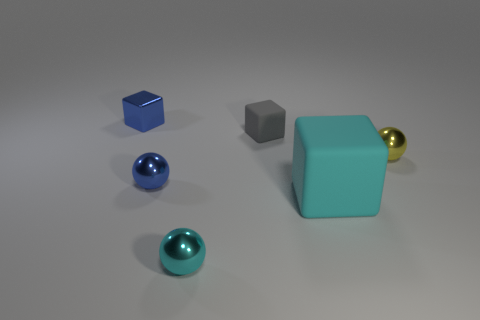Is there anything else that has the same material as the cyan ball?
Keep it short and to the point. Yes. How many tiny objects are either yellow shiny things or rubber cylinders?
Keep it short and to the point. 1. What number of things are small blue metallic things that are behind the gray thing or tiny blue balls?
Your answer should be compact. 2. Does the big thing have the same color as the small shiny block?
Give a very brief answer. No. How many other objects are there of the same shape as the gray rubber object?
Keep it short and to the point. 2. How many red things are big objects or metallic spheres?
Give a very brief answer. 0. There is a cube that is made of the same material as the blue ball; what is its color?
Offer a terse response. Blue. Is the object that is to the left of the tiny blue metal sphere made of the same material as the tiny blue object that is in front of the yellow metallic thing?
Provide a succinct answer. Yes. What size is the ball that is the same color as the big object?
Provide a succinct answer. Small. What is the tiny blue object that is in front of the gray block made of?
Provide a short and direct response. Metal. 